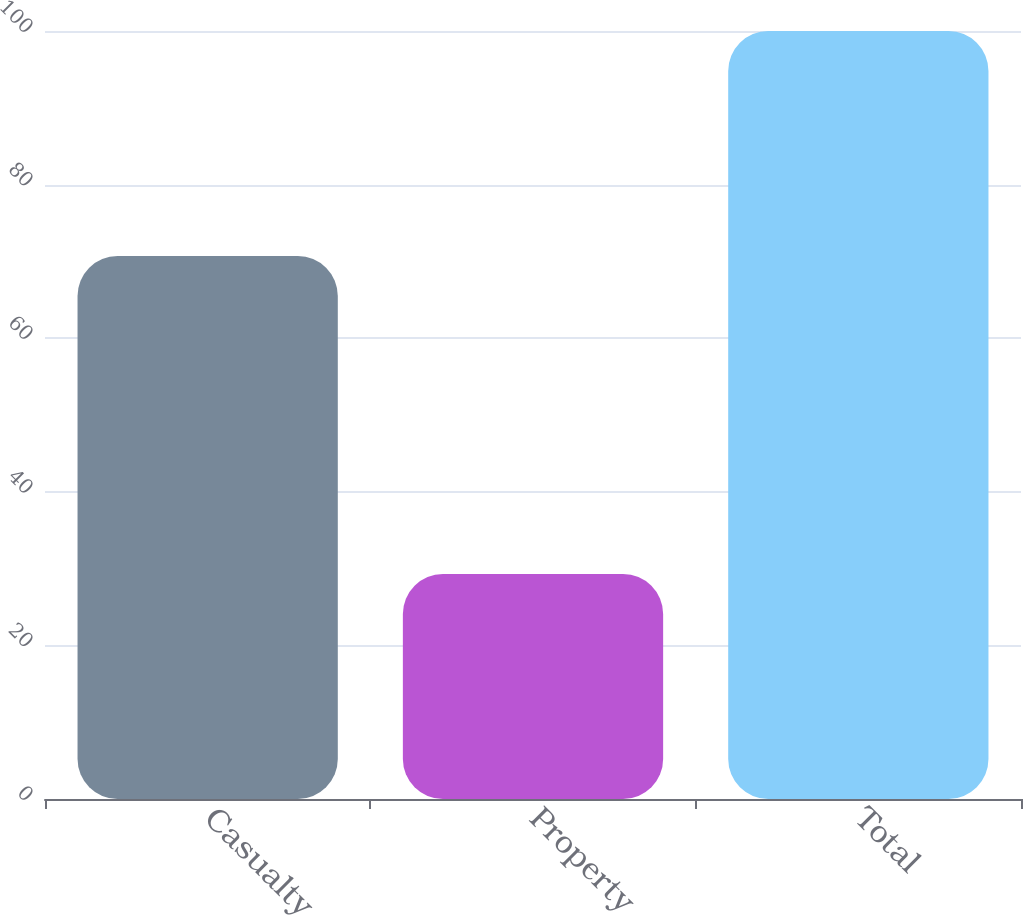Convert chart. <chart><loc_0><loc_0><loc_500><loc_500><bar_chart><fcel>Casualty<fcel>Property<fcel>Total<nl><fcel>70.7<fcel>29.3<fcel>100<nl></chart> 